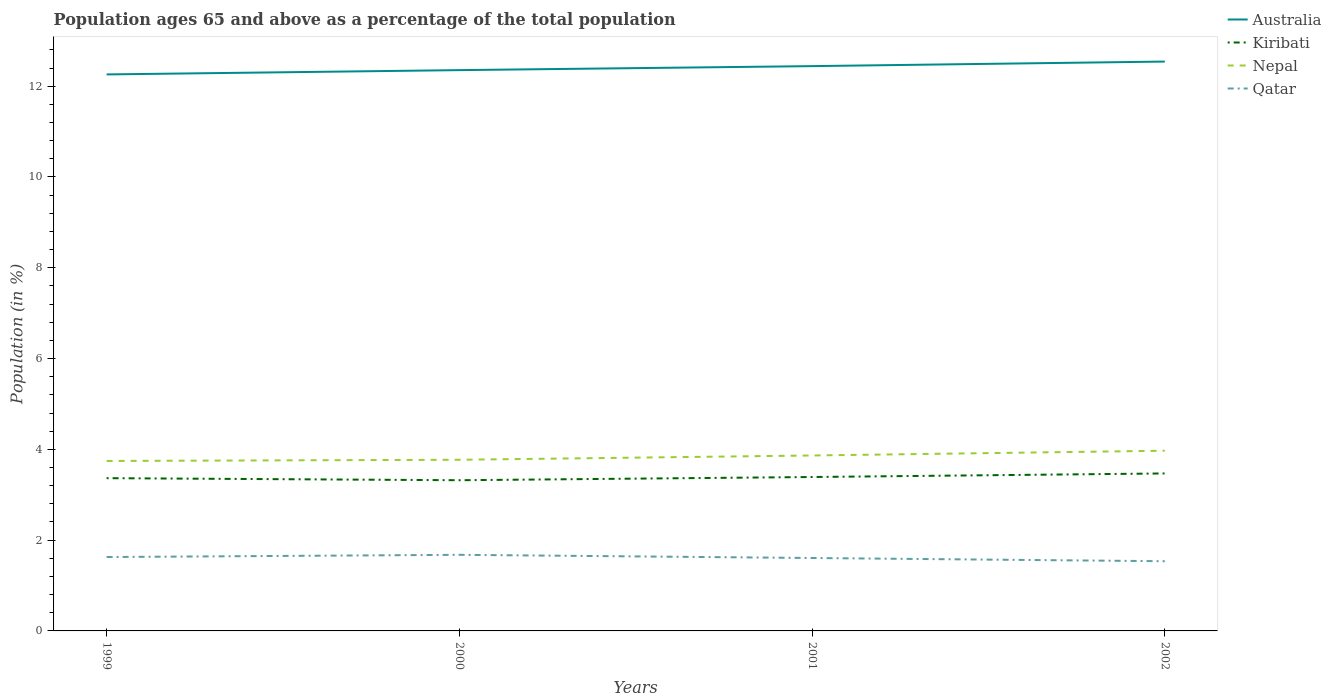How many different coloured lines are there?
Your response must be concise. 4. Is the number of lines equal to the number of legend labels?
Make the answer very short. Yes. Across all years, what is the maximum percentage of the population ages 65 and above in Nepal?
Provide a succinct answer. 3.74. In which year was the percentage of the population ages 65 and above in Nepal maximum?
Ensure brevity in your answer.  1999. What is the total percentage of the population ages 65 and above in Kiribati in the graph?
Offer a terse response. -0.15. What is the difference between the highest and the second highest percentage of the population ages 65 and above in Qatar?
Provide a succinct answer. 0.14. What is the difference between the highest and the lowest percentage of the population ages 65 and above in Nepal?
Ensure brevity in your answer.  2. Is the percentage of the population ages 65 and above in Australia strictly greater than the percentage of the population ages 65 and above in Kiribati over the years?
Offer a terse response. No. How many lines are there?
Your answer should be compact. 4. How many years are there in the graph?
Make the answer very short. 4. Are the values on the major ticks of Y-axis written in scientific E-notation?
Make the answer very short. No. Does the graph contain grids?
Provide a short and direct response. No. Where does the legend appear in the graph?
Your answer should be compact. Top right. What is the title of the graph?
Your response must be concise. Population ages 65 and above as a percentage of the total population. Does "Hungary" appear as one of the legend labels in the graph?
Provide a short and direct response. No. What is the label or title of the X-axis?
Offer a terse response. Years. What is the label or title of the Y-axis?
Offer a terse response. Population (in %). What is the Population (in %) of Australia in 1999?
Provide a succinct answer. 12.26. What is the Population (in %) of Kiribati in 1999?
Provide a short and direct response. 3.37. What is the Population (in %) of Nepal in 1999?
Make the answer very short. 3.74. What is the Population (in %) of Qatar in 1999?
Offer a terse response. 1.63. What is the Population (in %) in Australia in 2000?
Your response must be concise. 12.35. What is the Population (in %) in Kiribati in 2000?
Ensure brevity in your answer.  3.32. What is the Population (in %) of Nepal in 2000?
Your answer should be compact. 3.77. What is the Population (in %) in Qatar in 2000?
Ensure brevity in your answer.  1.68. What is the Population (in %) of Australia in 2001?
Your answer should be compact. 12.44. What is the Population (in %) in Kiribati in 2001?
Your response must be concise. 3.39. What is the Population (in %) in Nepal in 2001?
Provide a short and direct response. 3.86. What is the Population (in %) of Qatar in 2001?
Offer a terse response. 1.61. What is the Population (in %) in Australia in 2002?
Make the answer very short. 12.54. What is the Population (in %) of Kiribati in 2002?
Make the answer very short. 3.47. What is the Population (in %) of Nepal in 2002?
Give a very brief answer. 3.97. What is the Population (in %) in Qatar in 2002?
Offer a terse response. 1.54. Across all years, what is the maximum Population (in %) in Australia?
Provide a short and direct response. 12.54. Across all years, what is the maximum Population (in %) of Kiribati?
Offer a very short reply. 3.47. Across all years, what is the maximum Population (in %) of Nepal?
Your answer should be very brief. 3.97. Across all years, what is the maximum Population (in %) in Qatar?
Your answer should be very brief. 1.68. Across all years, what is the minimum Population (in %) in Australia?
Your response must be concise. 12.26. Across all years, what is the minimum Population (in %) in Kiribati?
Provide a succinct answer. 3.32. Across all years, what is the minimum Population (in %) of Nepal?
Give a very brief answer. 3.74. Across all years, what is the minimum Population (in %) of Qatar?
Give a very brief answer. 1.54. What is the total Population (in %) in Australia in the graph?
Provide a succinct answer. 49.6. What is the total Population (in %) of Kiribati in the graph?
Provide a succinct answer. 13.54. What is the total Population (in %) in Nepal in the graph?
Offer a terse response. 15.35. What is the total Population (in %) in Qatar in the graph?
Offer a very short reply. 6.45. What is the difference between the Population (in %) in Australia in 1999 and that in 2000?
Keep it short and to the point. -0.09. What is the difference between the Population (in %) in Kiribati in 1999 and that in 2000?
Offer a very short reply. 0.05. What is the difference between the Population (in %) of Nepal in 1999 and that in 2000?
Your response must be concise. -0.03. What is the difference between the Population (in %) in Qatar in 1999 and that in 2000?
Offer a very short reply. -0.05. What is the difference between the Population (in %) of Australia in 1999 and that in 2001?
Your response must be concise. -0.18. What is the difference between the Population (in %) of Kiribati in 1999 and that in 2001?
Your answer should be compact. -0.03. What is the difference between the Population (in %) in Nepal in 1999 and that in 2001?
Ensure brevity in your answer.  -0.12. What is the difference between the Population (in %) in Qatar in 1999 and that in 2001?
Your response must be concise. 0.02. What is the difference between the Population (in %) of Australia in 1999 and that in 2002?
Provide a short and direct response. -0.28. What is the difference between the Population (in %) of Kiribati in 1999 and that in 2002?
Give a very brief answer. -0.1. What is the difference between the Population (in %) in Nepal in 1999 and that in 2002?
Give a very brief answer. -0.23. What is the difference between the Population (in %) in Qatar in 1999 and that in 2002?
Make the answer very short. 0.09. What is the difference between the Population (in %) in Australia in 2000 and that in 2001?
Your answer should be very brief. -0.09. What is the difference between the Population (in %) of Kiribati in 2000 and that in 2001?
Offer a very short reply. -0.07. What is the difference between the Population (in %) of Nepal in 2000 and that in 2001?
Make the answer very short. -0.09. What is the difference between the Population (in %) of Qatar in 2000 and that in 2001?
Provide a short and direct response. 0.07. What is the difference between the Population (in %) in Australia in 2000 and that in 2002?
Keep it short and to the point. -0.19. What is the difference between the Population (in %) of Kiribati in 2000 and that in 2002?
Keep it short and to the point. -0.15. What is the difference between the Population (in %) of Nepal in 2000 and that in 2002?
Keep it short and to the point. -0.2. What is the difference between the Population (in %) of Qatar in 2000 and that in 2002?
Your answer should be very brief. 0.14. What is the difference between the Population (in %) in Australia in 2001 and that in 2002?
Make the answer very short. -0.1. What is the difference between the Population (in %) in Kiribati in 2001 and that in 2002?
Your answer should be very brief. -0.08. What is the difference between the Population (in %) in Nepal in 2001 and that in 2002?
Your answer should be very brief. -0.1. What is the difference between the Population (in %) of Qatar in 2001 and that in 2002?
Your answer should be very brief. 0.07. What is the difference between the Population (in %) of Australia in 1999 and the Population (in %) of Kiribati in 2000?
Make the answer very short. 8.94. What is the difference between the Population (in %) in Australia in 1999 and the Population (in %) in Nepal in 2000?
Offer a very short reply. 8.49. What is the difference between the Population (in %) in Australia in 1999 and the Population (in %) in Qatar in 2000?
Offer a very short reply. 10.58. What is the difference between the Population (in %) of Kiribati in 1999 and the Population (in %) of Nepal in 2000?
Your response must be concise. -0.41. What is the difference between the Population (in %) in Kiribati in 1999 and the Population (in %) in Qatar in 2000?
Give a very brief answer. 1.69. What is the difference between the Population (in %) in Nepal in 1999 and the Population (in %) in Qatar in 2000?
Your response must be concise. 2.07. What is the difference between the Population (in %) in Australia in 1999 and the Population (in %) in Kiribati in 2001?
Your answer should be compact. 8.87. What is the difference between the Population (in %) of Australia in 1999 and the Population (in %) of Nepal in 2001?
Your response must be concise. 8.39. What is the difference between the Population (in %) in Australia in 1999 and the Population (in %) in Qatar in 2001?
Provide a short and direct response. 10.65. What is the difference between the Population (in %) in Kiribati in 1999 and the Population (in %) in Nepal in 2001?
Provide a short and direct response. -0.5. What is the difference between the Population (in %) in Kiribati in 1999 and the Population (in %) in Qatar in 2001?
Provide a succinct answer. 1.76. What is the difference between the Population (in %) in Nepal in 1999 and the Population (in %) in Qatar in 2001?
Your answer should be very brief. 2.14. What is the difference between the Population (in %) in Australia in 1999 and the Population (in %) in Kiribati in 2002?
Make the answer very short. 8.79. What is the difference between the Population (in %) in Australia in 1999 and the Population (in %) in Nepal in 2002?
Your response must be concise. 8.29. What is the difference between the Population (in %) of Australia in 1999 and the Population (in %) of Qatar in 2002?
Offer a very short reply. 10.72. What is the difference between the Population (in %) in Kiribati in 1999 and the Population (in %) in Nepal in 2002?
Ensure brevity in your answer.  -0.6. What is the difference between the Population (in %) in Kiribati in 1999 and the Population (in %) in Qatar in 2002?
Offer a very short reply. 1.83. What is the difference between the Population (in %) of Nepal in 1999 and the Population (in %) of Qatar in 2002?
Your response must be concise. 2.21. What is the difference between the Population (in %) of Australia in 2000 and the Population (in %) of Kiribati in 2001?
Provide a succinct answer. 8.96. What is the difference between the Population (in %) of Australia in 2000 and the Population (in %) of Nepal in 2001?
Give a very brief answer. 8.49. What is the difference between the Population (in %) in Australia in 2000 and the Population (in %) in Qatar in 2001?
Keep it short and to the point. 10.75. What is the difference between the Population (in %) in Kiribati in 2000 and the Population (in %) in Nepal in 2001?
Offer a terse response. -0.55. What is the difference between the Population (in %) of Kiribati in 2000 and the Population (in %) of Qatar in 2001?
Your answer should be very brief. 1.71. What is the difference between the Population (in %) of Nepal in 2000 and the Population (in %) of Qatar in 2001?
Keep it short and to the point. 2.16. What is the difference between the Population (in %) in Australia in 2000 and the Population (in %) in Kiribati in 2002?
Provide a short and direct response. 8.88. What is the difference between the Population (in %) in Australia in 2000 and the Population (in %) in Nepal in 2002?
Ensure brevity in your answer.  8.38. What is the difference between the Population (in %) of Australia in 2000 and the Population (in %) of Qatar in 2002?
Offer a terse response. 10.82. What is the difference between the Population (in %) of Kiribati in 2000 and the Population (in %) of Nepal in 2002?
Provide a succinct answer. -0.65. What is the difference between the Population (in %) of Kiribati in 2000 and the Population (in %) of Qatar in 2002?
Your answer should be compact. 1.78. What is the difference between the Population (in %) of Nepal in 2000 and the Population (in %) of Qatar in 2002?
Your response must be concise. 2.23. What is the difference between the Population (in %) in Australia in 2001 and the Population (in %) in Kiribati in 2002?
Keep it short and to the point. 8.97. What is the difference between the Population (in %) of Australia in 2001 and the Population (in %) of Nepal in 2002?
Your response must be concise. 8.47. What is the difference between the Population (in %) in Australia in 2001 and the Population (in %) in Qatar in 2002?
Give a very brief answer. 10.91. What is the difference between the Population (in %) in Kiribati in 2001 and the Population (in %) in Nepal in 2002?
Offer a very short reply. -0.58. What is the difference between the Population (in %) in Kiribati in 2001 and the Population (in %) in Qatar in 2002?
Give a very brief answer. 1.86. What is the difference between the Population (in %) in Nepal in 2001 and the Population (in %) in Qatar in 2002?
Your answer should be very brief. 2.33. What is the average Population (in %) of Australia per year?
Provide a short and direct response. 12.4. What is the average Population (in %) of Kiribati per year?
Make the answer very short. 3.39. What is the average Population (in %) of Nepal per year?
Give a very brief answer. 3.84. What is the average Population (in %) in Qatar per year?
Give a very brief answer. 1.61. In the year 1999, what is the difference between the Population (in %) of Australia and Population (in %) of Kiribati?
Keep it short and to the point. 8.89. In the year 1999, what is the difference between the Population (in %) in Australia and Population (in %) in Nepal?
Your answer should be compact. 8.52. In the year 1999, what is the difference between the Population (in %) of Australia and Population (in %) of Qatar?
Your response must be concise. 10.63. In the year 1999, what is the difference between the Population (in %) of Kiribati and Population (in %) of Nepal?
Offer a very short reply. -0.38. In the year 1999, what is the difference between the Population (in %) in Kiribati and Population (in %) in Qatar?
Make the answer very short. 1.74. In the year 1999, what is the difference between the Population (in %) in Nepal and Population (in %) in Qatar?
Your response must be concise. 2.12. In the year 2000, what is the difference between the Population (in %) in Australia and Population (in %) in Kiribati?
Offer a very short reply. 9.03. In the year 2000, what is the difference between the Population (in %) in Australia and Population (in %) in Nepal?
Your response must be concise. 8.58. In the year 2000, what is the difference between the Population (in %) in Australia and Population (in %) in Qatar?
Provide a succinct answer. 10.68. In the year 2000, what is the difference between the Population (in %) in Kiribati and Population (in %) in Nepal?
Provide a succinct answer. -0.45. In the year 2000, what is the difference between the Population (in %) in Kiribati and Population (in %) in Qatar?
Your answer should be very brief. 1.64. In the year 2000, what is the difference between the Population (in %) in Nepal and Population (in %) in Qatar?
Provide a short and direct response. 2.09. In the year 2001, what is the difference between the Population (in %) in Australia and Population (in %) in Kiribati?
Provide a succinct answer. 9.05. In the year 2001, what is the difference between the Population (in %) of Australia and Population (in %) of Nepal?
Provide a short and direct response. 8.58. In the year 2001, what is the difference between the Population (in %) of Australia and Population (in %) of Qatar?
Provide a succinct answer. 10.84. In the year 2001, what is the difference between the Population (in %) of Kiribati and Population (in %) of Nepal?
Provide a short and direct response. -0.47. In the year 2001, what is the difference between the Population (in %) in Kiribati and Population (in %) in Qatar?
Make the answer very short. 1.78. In the year 2001, what is the difference between the Population (in %) of Nepal and Population (in %) of Qatar?
Your answer should be compact. 2.26. In the year 2002, what is the difference between the Population (in %) of Australia and Population (in %) of Kiribati?
Provide a succinct answer. 9.07. In the year 2002, what is the difference between the Population (in %) in Australia and Population (in %) in Nepal?
Provide a succinct answer. 8.57. In the year 2002, what is the difference between the Population (in %) in Australia and Population (in %) in Qatar?
Your response must be concise. 11.01. In the year 2002, what is the difference between the Population (in %) of Kiribati and Population (in %) of Nepal?
Ensure brevity in your answer.  -0.5. In the year 2002, what is the difference between the Population (in %) of Kiribati and Population (in %) of Qatar?
Keep it short and to the point. 1.93. In the year 2002, what is the difference between the Population (in %) of Nepal and Population (in %) of Qatar?
Offer a very short reply. 2.43. What is the ratio of the Population (in %) in Australia in 1999 to that in 2000?
Make the answer very short. 0.99. What is the ratio of the Population (in %) in Kiribati in 1999 to that in 2000?
Your response must be concise. 1.01. What is the ratio of the Population (in %) of Qatar in 1999 to that in 2000?
Make the answer very short. 0.97. What is the ratio of the Population (in %) in Australia in 1999 to that in 2001?
Give a very brief answer. 0.99. What is the ratio of the Population (in %) in Nepal in 1999 to that in 2001?
Keep it short and to the point. 0.97. What is the ratio of the Population (in %) of Qatar in 1999 to that in 2001?
Make the answer very short. 1.01. What is the ratio of the Population (in %) in Australia in 1999 to that in 2002?
Your answer should be very brief. 0.98. What is the ratio of the Population (in %) of Nepal in 1999 to that in 2002?
Offer a terse response. 0.94. What is the ratio of the Population (in %) in Qatar in 1999 to that in 2002?
Give a very brief answer. 1.06. What is the ratio of the Population (in %) of Australia in 2000 to that in 2001?
Your answer should be very brief. 0.99. What is the ratio of the Population (in %) in Kiribati in 2000 to that in 2001?
Give a very brief answer. 0.98. What is the ratio of the Population (in %) of Nepal in 2000 to that in 2001?
Provide a short and direct response. 0.98. What is the ratio of the Population (in %) of Qatar in 2000 to that in 2001?
Your answer should be very brief. 1.04. What is the ratio of the Population (in %) of Australia in 2000 to that in 2002?
Your answer should be compact. 0.98. What is the ratio of the Population (in %) of Kiribati in 2000 to that in 2002?
Ensure brevity in your answer.  0.96. What is the ratio of the Population (in %) of Nepal in 2000 to that in 2002?
Keep it short and to the point. 0.95. What is the ratio of the Population (in %) in Qatar in 2000 to that in 2002?
Your answer should be very brief. 1.09. What is the ratio of the Population (in %) in Australia in 2001 to that in 2002?
Offer a terse response. 0.99. What is the ratio of the Population (in %) of Kiribati in 2001 to that in 2002?
Your answer should be very brief. 0.98. What is the ratio of the Population (in %) in Nepal in 2001 to that in 2002?
Make the answer very short. 0.97. What is the ratio of the Population (in %) in Qatar in 2001 to that in 2002?
Give a very brief answer. 1.05. What is the difference between the highest and the second highest Population (in %) in Australia?
Your answer should be compact. 0.1. What is the difference between the highest and the second highest Population (in %) in Kiribati?
Make the answer very short. 0.08. What is the difference between the highest and the second highest Population (in %) in Nepal?
Offer a very short reply. 0.1. What is the difference between the highest and the second highest Population (in %) of Qatar?
Provide a short and direct response. 0.05. What is the difference between the highest and the lowest Population (in %) of Australia?
Offer a very short reply. 0.28. What is the difference between the highest and the lowest Population (in %) in Kiribati?
Keep it short and to the point. 0.15. What is the difference between the highest and the lowest Population (in %) in Nepal?
Your answer should be very brief. 0.23. What is the difference between the highest and the lowest Population (in %) of Qatar?
Ensure brevity in your answer.  0.14. 